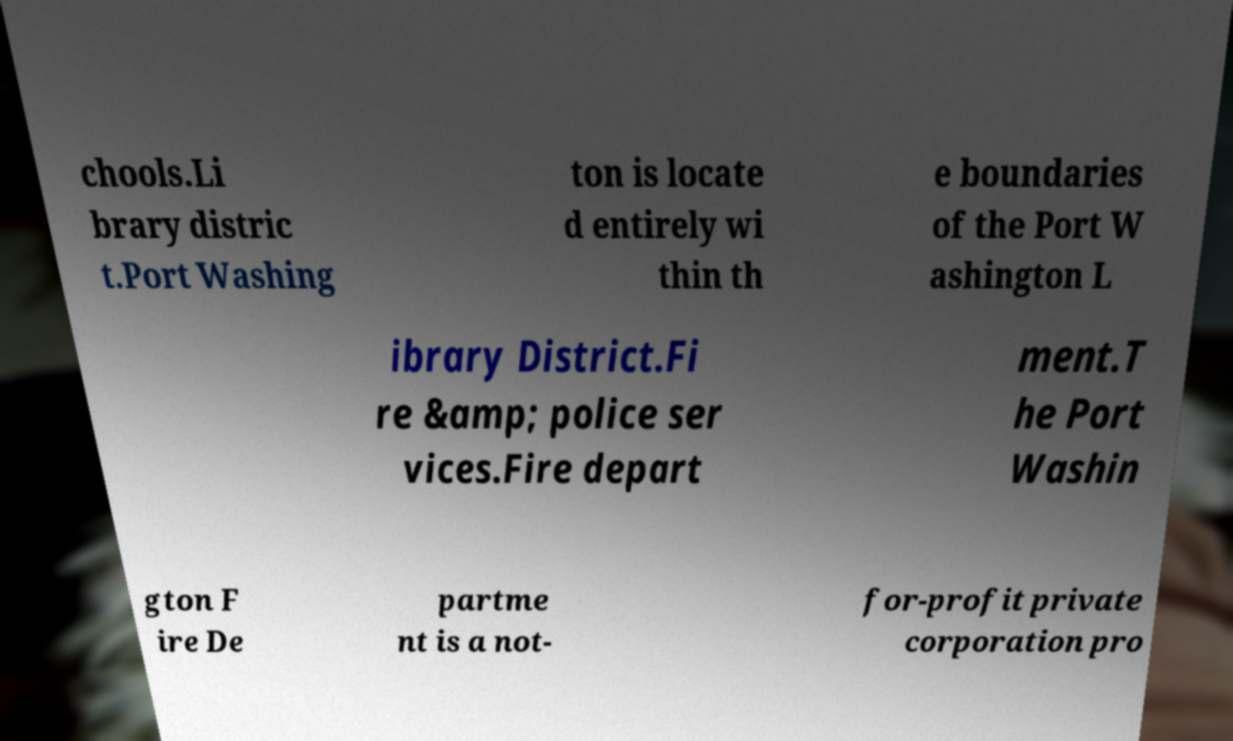Could you assist in decoding the text presented in this image and type it out clearly? chools.Li brary distric t.Port Washing ton is locate d entirely wi thin th e boundaries of the Port W ashington L ibrary District.Fi re &amp; police ser vices.Fire depart ment.T he Port Washin gton F ire De partme nt is a not- for-profit private corporation pro 